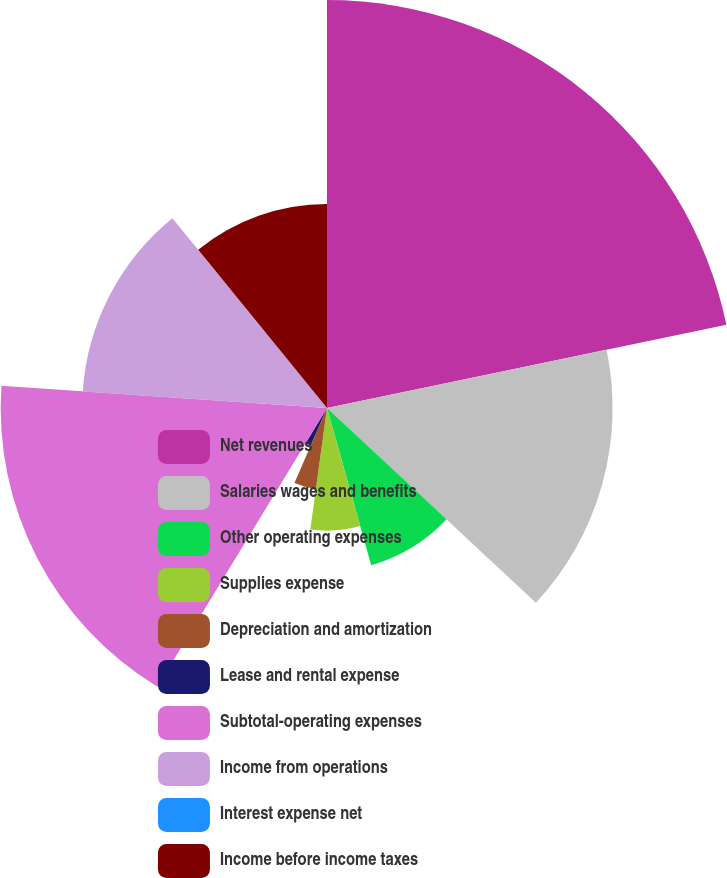Convert chart. <chart><loc_0><loc_0><loc_500><loc_500><pie_chart><fcel>Net revenues<fcel>Salaries wages and benefits<fcel>Other operating expenses<fcel>Supplies expense<fcel>Depreciation and amortization<fcel>Lease and rental expense<fcel>Subtotal-operating expenses<fcel>Income from operations<fcel>Interest expense net<fcel>Income before income taxes<nl><fcel>21.73%<fcel>15.21%<fcel>8.7%<fcel>6.53%<fcel>4.35%<fcel>2.18%<fcel>17.38%<fcel>13.04%<fcel>0.01%<fcel>10.87%<nl></chart> 